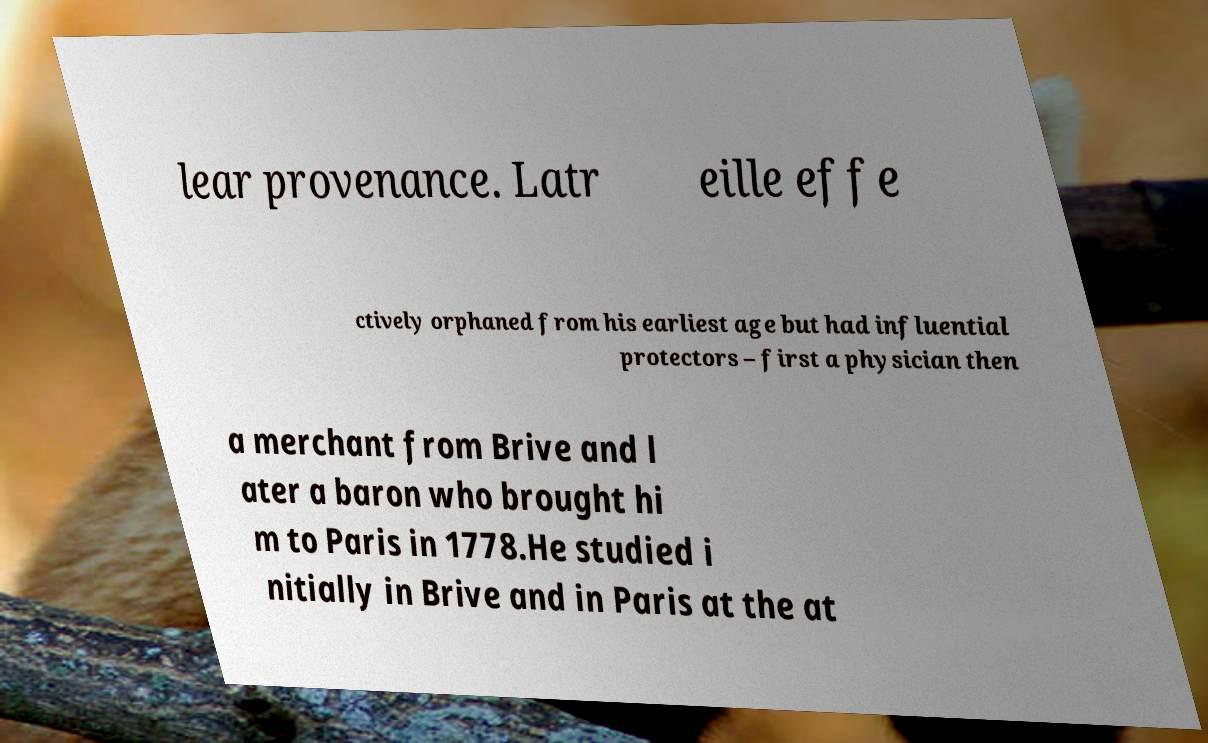Can you read and provide the text displayed in the image?This photo seems to have some interesting text. Can you extract and type it out for me? lear provenance. Latr eille effe ctively orphaned from his earliest age but had influential protectors – first a physician then a merchant from Brive and l ater a baron who brought hi m to Paris in 1778.He studied i nitially in Brive and in Paris at the at 